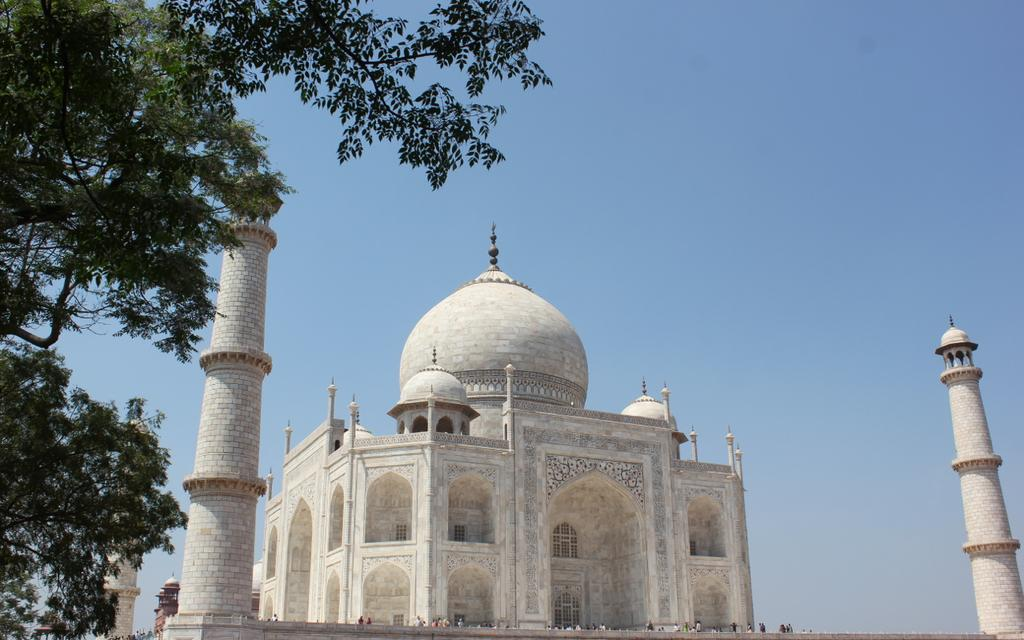What famous landmark is visible in the image? The Taj Mahal is visible in the image. What type of natural elements can be seen in the image? There are trees in the image. Are there any people present in the image? Yes, there is a group of people in the image. What can be seen in the background of the image? The sky is visible in the background of the image. What type of toy can be seen being played with by the group of people in the image? There is no toy present in the image; it features the Taj Mahal, trees, a group of people, and the sky in the background. 